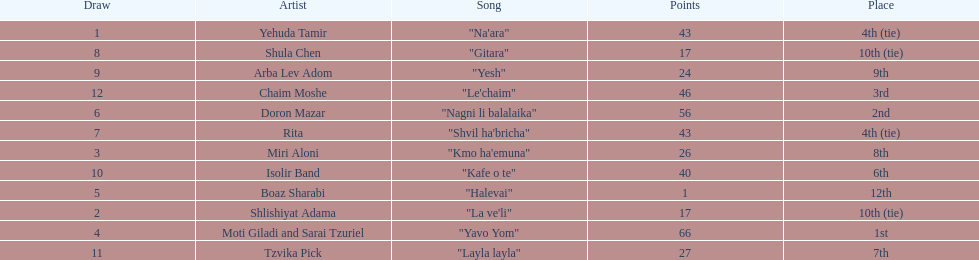Compare draws, which had the least amount of points? Boaz Sharabi. 